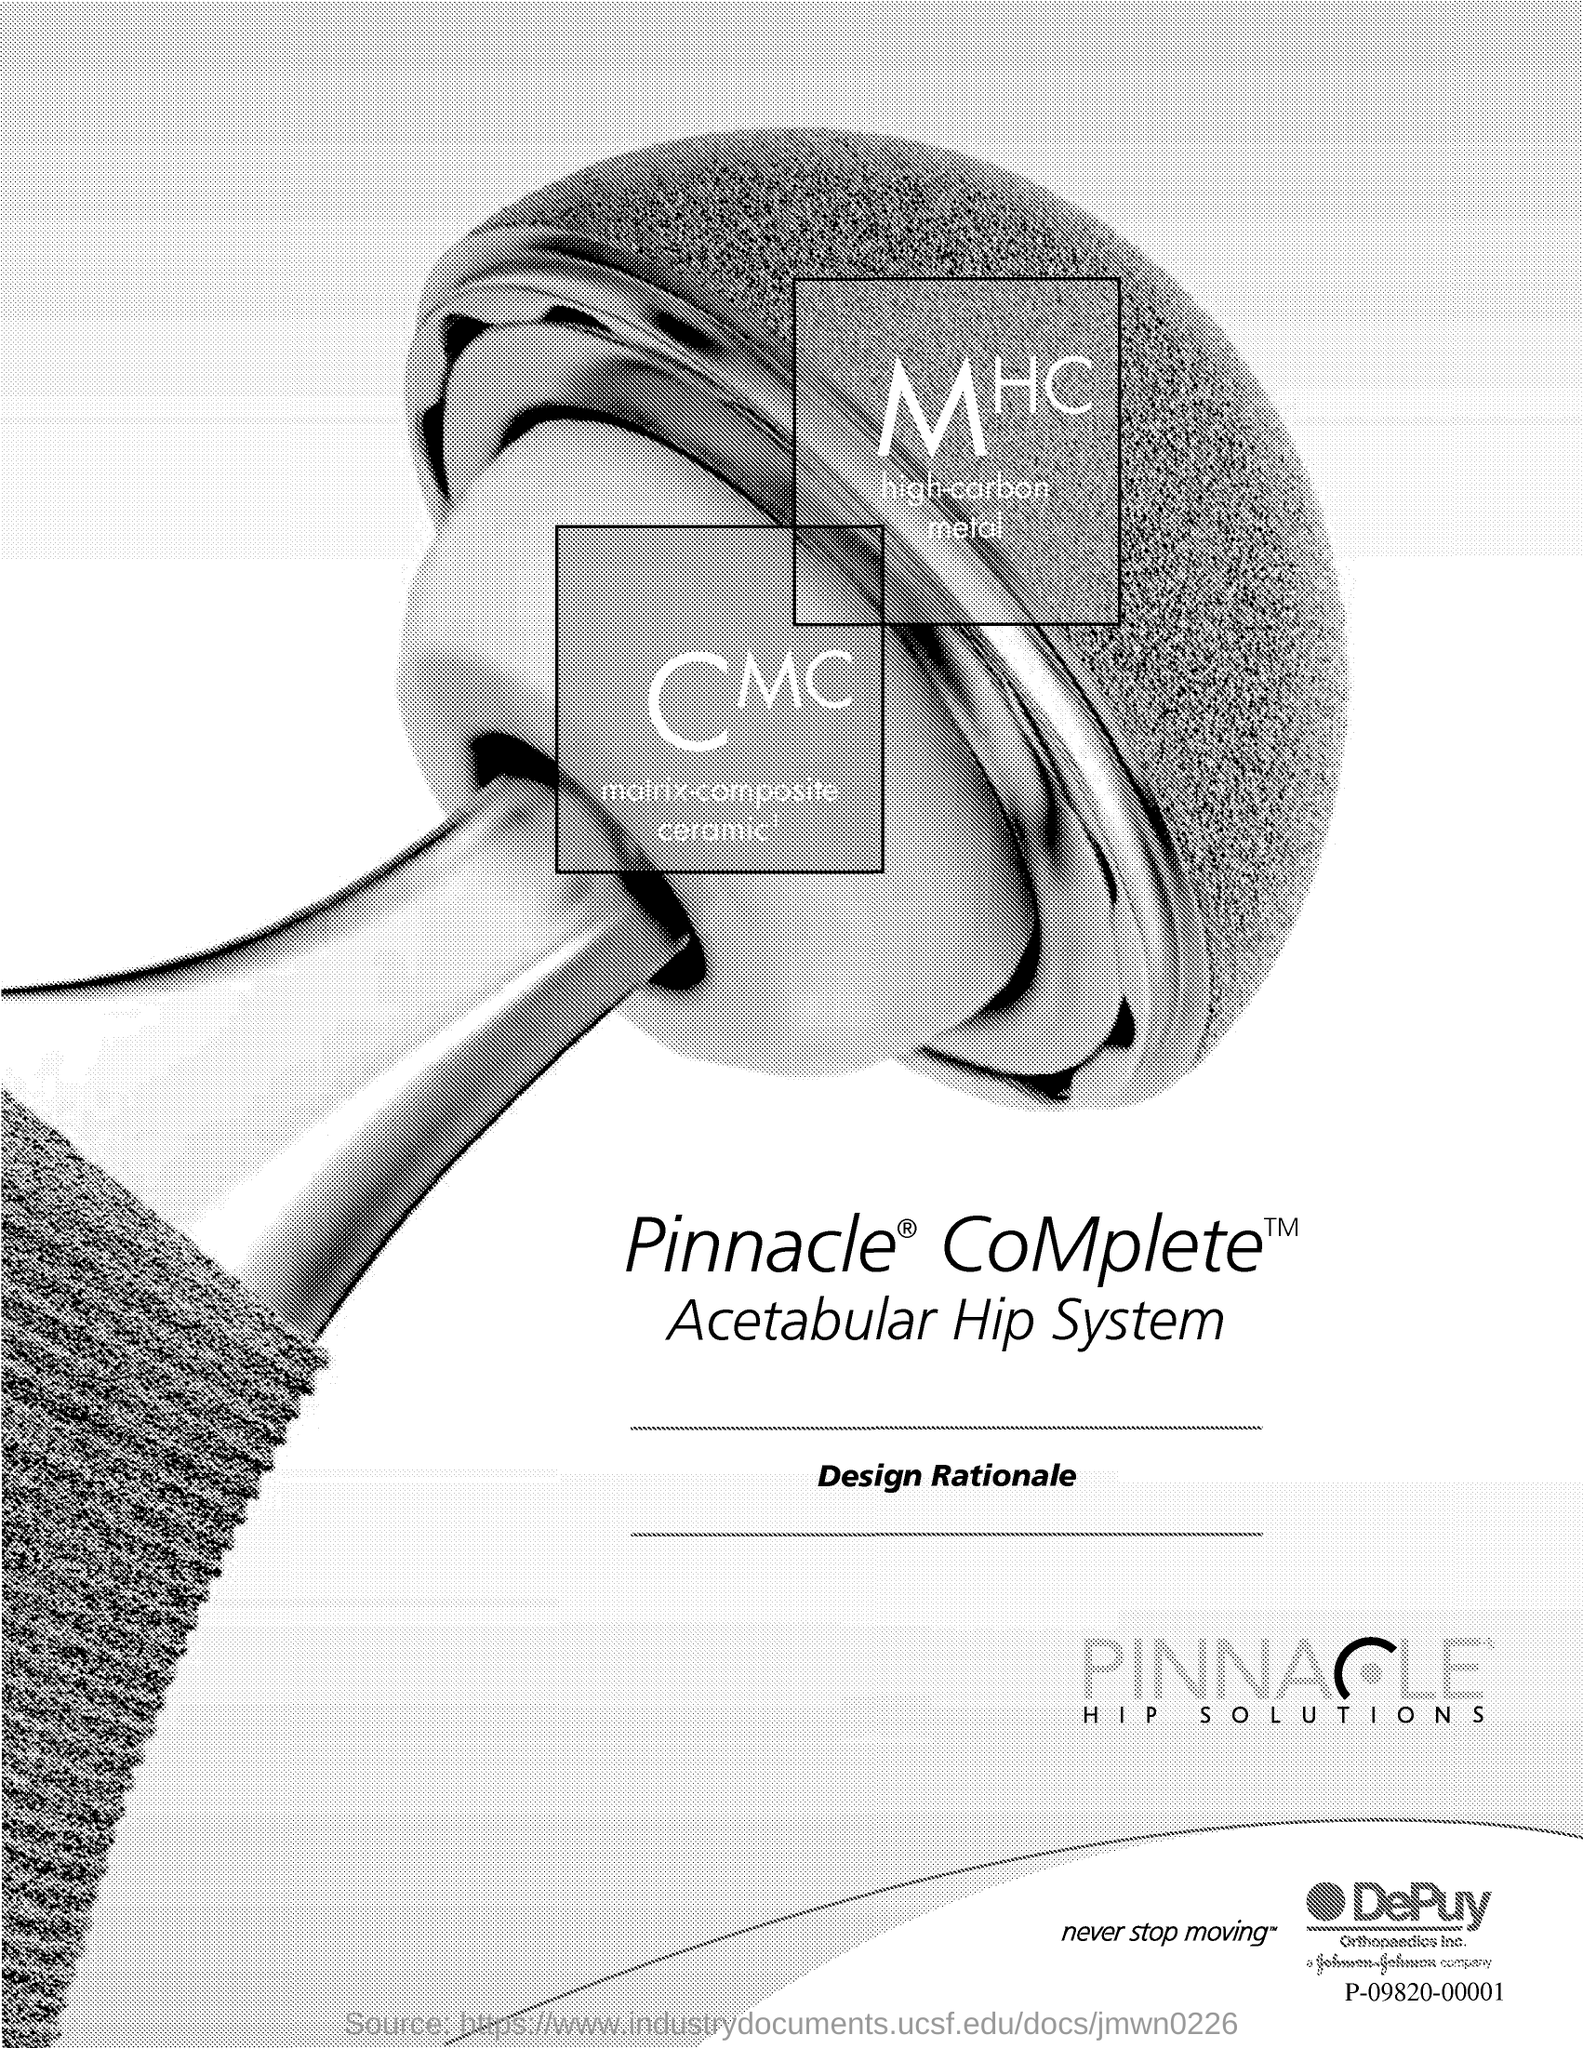Give some essential details in this illustration. The title 'Design Rationale' is written in-between two lines. 